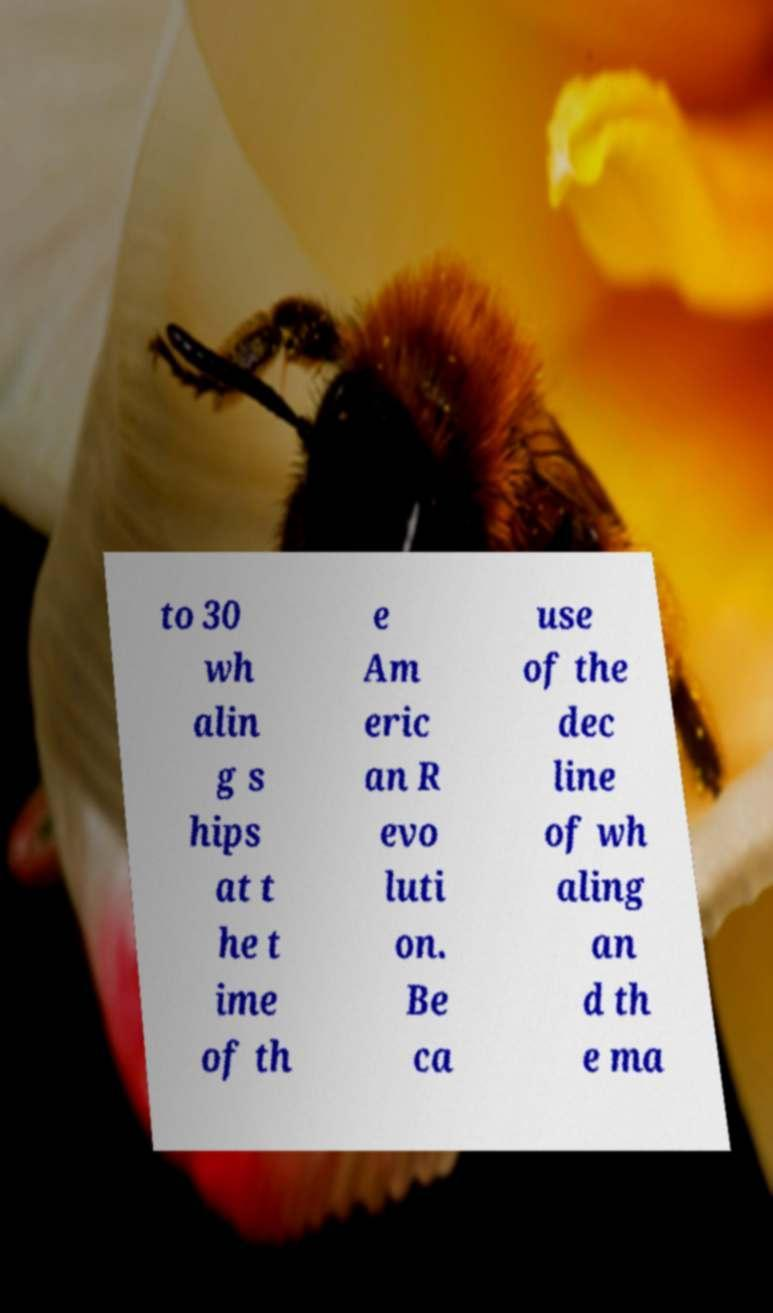What messages or text are displayed in this image? I need them in a readable, typed format. to 30 wh alin g s hips at t he t ime of th e Am eric an R evo luti on. Be ca use of the dec line of wh aling an d th e ma 